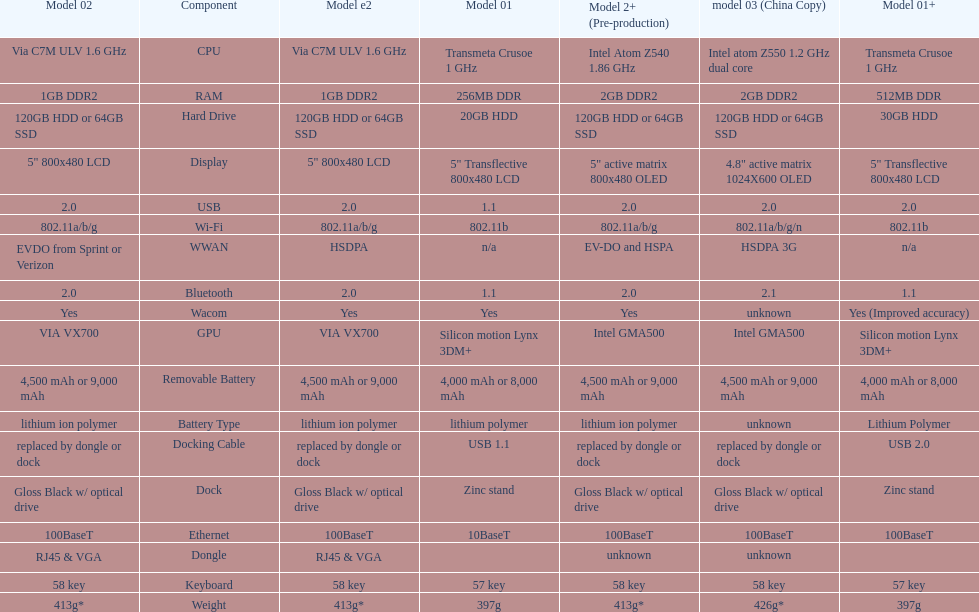What is the next highest hard drive available after the 30gb model? 64GB SSD. 